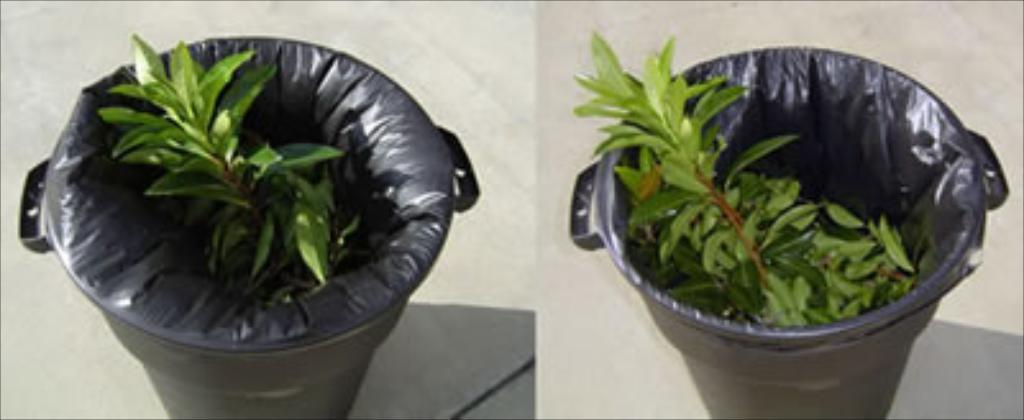How would you summarize this image in a sentence or two? In this picture we can see bins with leaves and plastic covers in it and these are placed on a platform. 